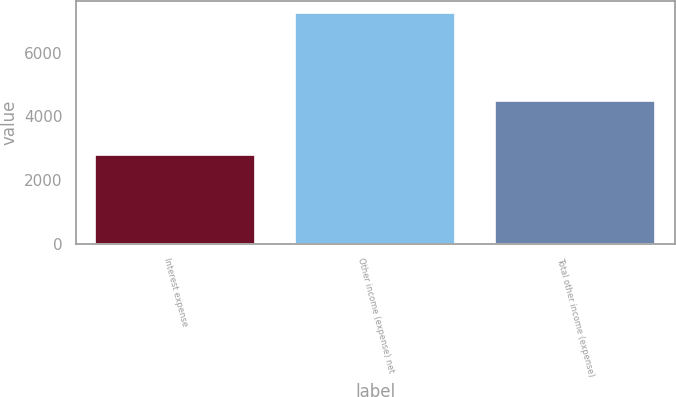<chart> <loc_0><loc_0><loc_500><loc_500><bar_chart><fcel>Interest expense<fcel>Other income (expense) net<fcel>Total other income (expense)<nl><fcel>2780<fcel>7268<fcel>4488<nl></chart> 